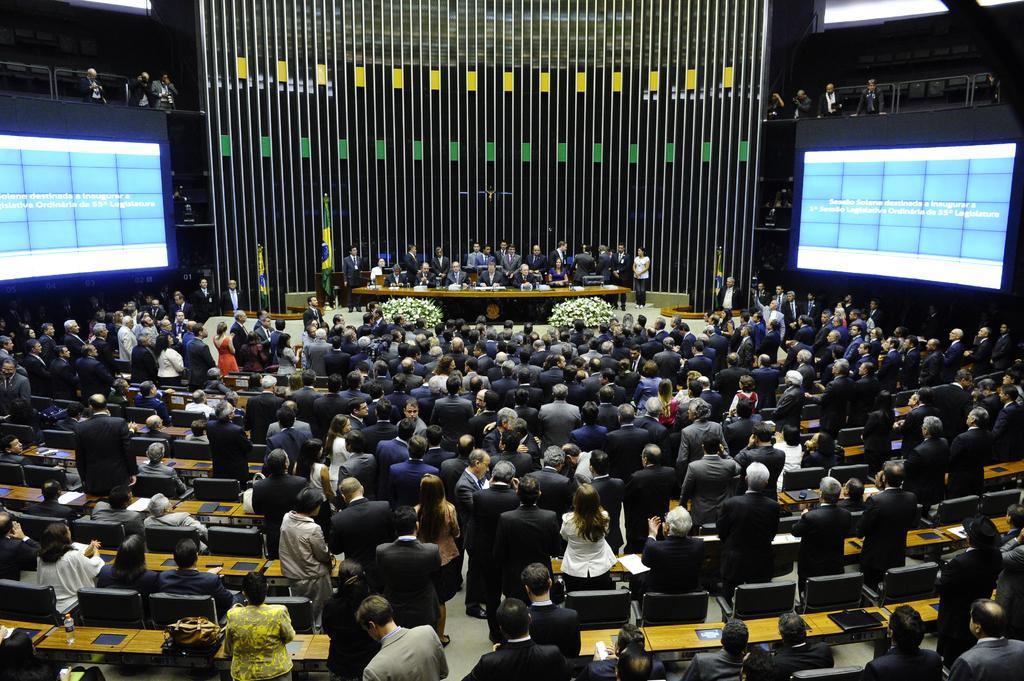Could you give a brief overview of what you see in this image? In the middle of the image few people are standing, sitting and we can see some tables, on the tables we can see some books, bottles and laptops. At the top of the image we can see wall and screen. 